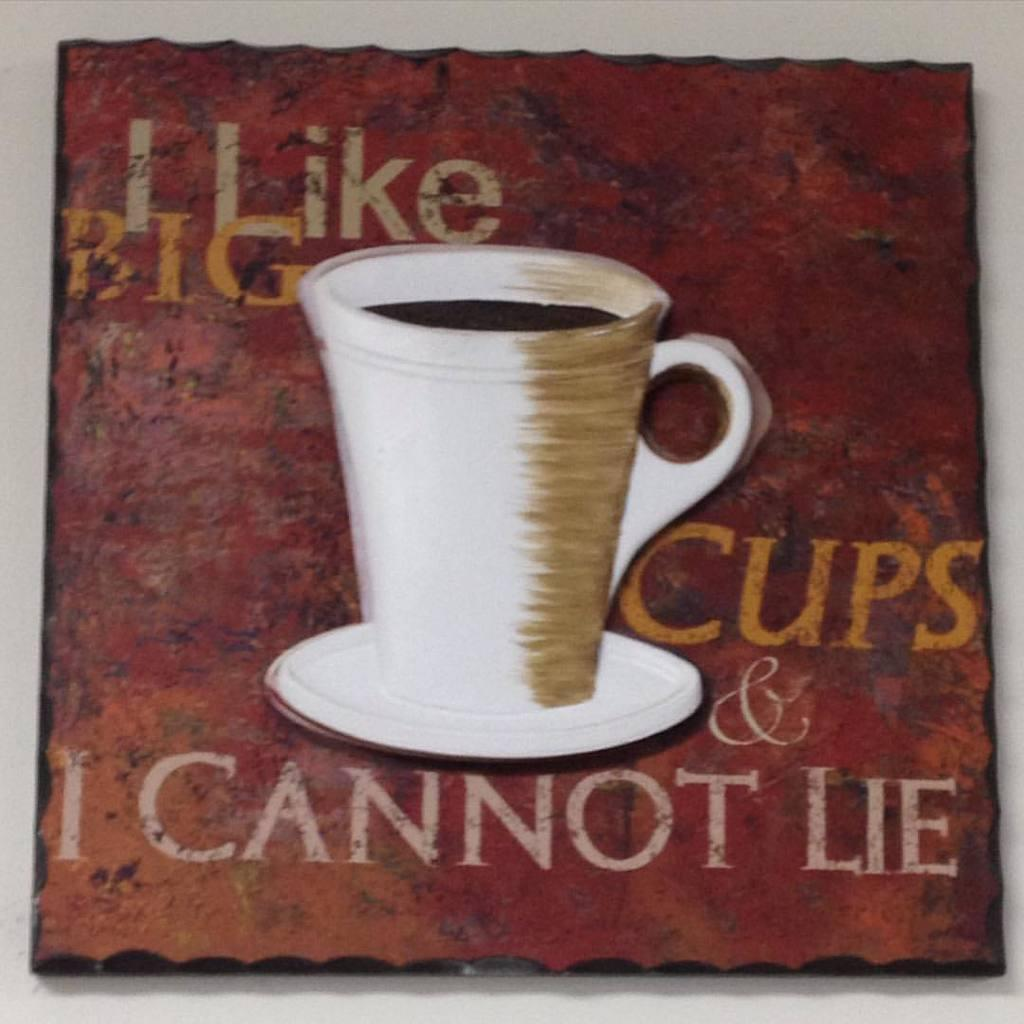<image>
Create a compact narrative representing the image presented. I painting of a coffee mug with the caption "I like big cups & I cannot lie" 